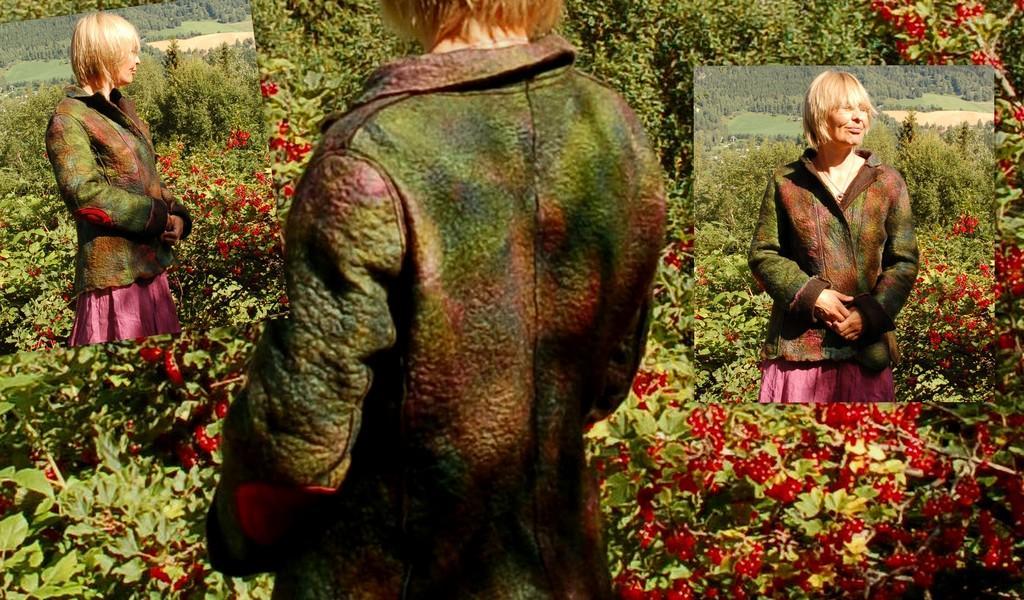Describe this image in one or two sentences. This is edited picture, in these pictures we can see same woman. We can see plants, fruits and trees. 